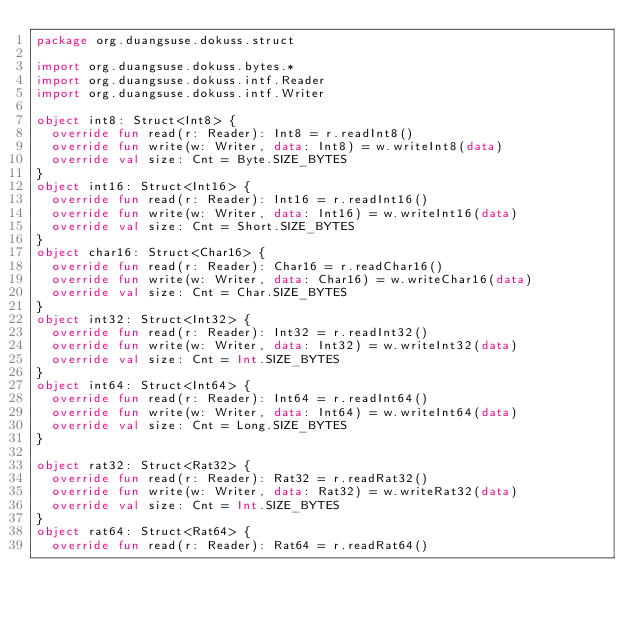Convert code to text. <code><loc_0><loc_0><loc_500><loc_500><_Kotlin_>package org.duangsuse.dokuss.struct

import org.duangsuse.dokuss.bytes.*
import org.duangsuse.dokuss.intf.Reader
import org.duangsuse.dokuss.intf.Writer

object int8: Struct<Int8> {
  override fun read(r: Reader): Int8 = r.readInt8()
  override fun write(w: Writer, data: Int8) = w.writeInt8(data)
  override val size: Cnt = Byte.SIZE_BYTES
}
object int16: Struct<Int16> {
  override fun read(r: Reader): Int16 = r.readInt16()
  override fun write(w: Writer, data: Int16) = w.writeInt16(data)
  override val size: Cnt = Short.SIZE_BYTES
}
object char16: Struct<Char16> {
  override fun read(r: Reader): Char16 = r.readChar16()
  override fun write(w: Writer, data: Char16) = w.writeChar16(data)
  override val size: Cnt = Char.SIZE_BYTES
}
object int32: Struct<Int32> {
  override fun read(r: Reader): Int32 = r.readInt32()
  override fun write(w: Writer, data: Int32) = w.writeInt32(data)
  override val size: Cnt = Int.SIZE_BYTES
}
object int64: Struct<Int64> {
  override fun read(r: Reader): Int64 = r.readInt64()
  override fun write(w: Writer, data: Int64) = w.writeInt64(data)
  override val size: Cnt = Long.SIZE_BYTES
}

object rat32: Struct<Rat32> {
  override fun read(r: Reader): Rat32 = r.readRat32()
  override fun write(w: Writer, data: Rat32) = w.writeRat32(data)
  override val size: Cnt = Int.SIZE_BYTES
}
object rat64: Struct<Rat64> {
  override fun read(r: Reader): Rat64 = r.readRat64()</code> 